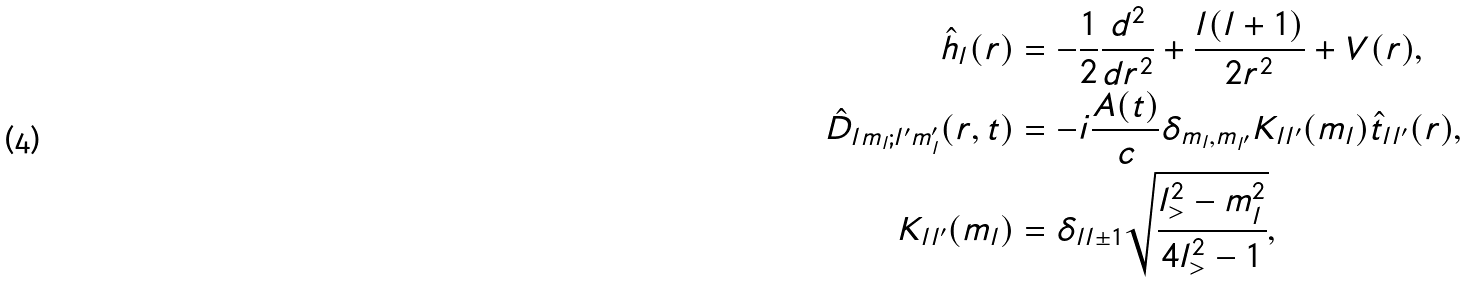<formula> <loc_0><loc_0><loc_500><loc_500>\hat { h } _ { l } ( r ) & = - \frac { 1 } { 2 } \frac { d ^ { 2 } } { d r ^ { 2 } } + \frac { l ( l + 1 ) } { 2 r ^ { 2 } } + V ( r ) , \\ \hat { D } _ { l m _ { l } ; l ^ { \prime } m _ { l } ^ { \prime } } ( r , t ) & = - i \frac { A ( t ) } { c } \delta _ { m _ { l } , m _ { l ^ { \prime } } } K _ { l l ^ { \prime } } ( m _ { l } ) \hat { t } _ { l l ^ { \prime } } ( r ) , \\ K _ { l l ^ { \prime } } ( m _ { l } ) & = \delta _ { l l \pm 1 } \sqrt { \frac { l _ { > } ^ { 2 } - m _ { l } ^ { 2 } } { 4 l _ { > } ^ { 2 } - 1 } } ,</formula> 